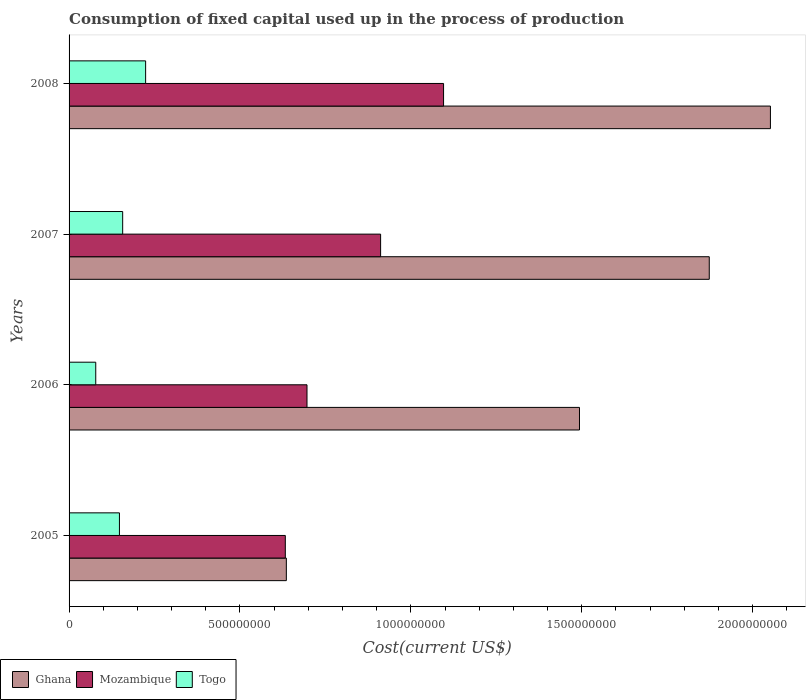Are the number of bars per tick equal to the number of legend labels?
Give a very brief answer. Yes. Are the number of bars on each tick of the Y-axis equal?
Give a very brief answer. Yes. How many bars are there on the 4th tick from the top?
Make the answer very short. 3. How many bars are there on the 2nd tick from the bottom?
Offer a very short reply. 3. What is the amount consumed in the process of production in Mozambique in 2007?
Your response must be concise. 9.12e+08. Across all years, what is the maximum amount consumed in the process of production in Togo?
Keep it short and to the point. 2.24e+08. Across all years, what is the minimum amount consumed in the process of production in Mozambique?
Offer a very short reply. 6.33e+08. In which year was the amount consumed in the process of production in Mozambique minimum?
Your response must be concise. 2005. What is the total amount consumed in the process of production in Ghana in the graph?
Your answer should be very brief. 6.05e+09. What is the difference between the amount consumed in the process of production in Mozambique in 2005 and that in 2007?
Offer a terse response. -2.79e+08. What is the difference between the amount consumed in the process of production in Togo in 2006 and the amount consumed in the process of production in Ghana in 2007?
Your response must be concise. -1.80e+09. What is the average amount consumed in the process of production in Ghana per year?
Keep it short and to the point. 1.51e+09. In the year 2005, what is the difference between the amount consumed in the process of production in Mozambique and amount consumed in the process of production in Togo?
Make the answer very short. 4.85e+08. In how many years, is the amount consumed in the process of production in Ghana greater than 1800000000 US$?
Make the answer very short. 2. What is the ratio of the amount consumed in the process of production in Togo in 2006 to that in 2008?
Your response must be concise. 0.35. What is the difference between the highest and the second highest amount consumed in the process of production in Mozambique?
Offer a very short reply. 1.84e+08. What is the difference between the highest and the lowest amount consumed in the process of production in Mozambique?
Make the answer very short. 4.63e+08. What does the 2nd bar from the top in 2006 represents?
Provide a short and direct response. Mozambique. Is it the case that in every year, the sum of the amount consumed in the process of production in Togo and amount consumed in the process of production in Mozambique is greater than the amount consumed in the process of production in Ghana?
Your answer should be very brief. No. Are all the bars in the graph horizontal?
Make the answer very short. Yes. How many years are there in the graph?
Your response must be concise. 4. What is the difference between two consecutive major ticks on the X-axis?
Give a very brief answer. 5.00e+08. Are the values on the major ticks of X-axis written in scientific E-notation?
Offer a very short reply. No. Does the graph contain any zero values?
Give a very brief answer. No. How many legend labels are there?
Provide a succinct answer. 3. How are the legend labels stacked?
Ensure brevity in your answer.  Horizontal. What is the title of the graph?
Offer a terse response. Consumption of fixed capital used up in the process of production. Does "Madagascar" appear as one of the legend labels in the graph?
Make the answer very short. No. What is the label or title of the X-axis?
Provide a short and direct response. Cost(current US$). What is the Cost(current US$) of Ghana in 2005?
Your answer should be very brief. 6.36e+08. What is the Cost(current US$) of Mozambique in 2005?
Make the answer very short. 6.33e+08. What is the Cost(current US$) of Togo in 2005?
Give a very brief answer. 1.47e+08. What is the Cost(current US$) in Ghana in 2006?
Give a very brief answer. 1.49e+09. What is the Cost(current US$) of Mozambique in 2006?
Provide a short and direct response. 6.96e+08. What is the Cost(current US$) in Togo in 2006?
Provide a succinct answer. 7.81e+07. What is the Cost(current US$) of Ghana in 2007?
Make the answer very short. 1.87e+09. What is the Cost(current US$) of Mozambique in 2007?
Give a very brief answer. 9.12e+08. What is the Cost(current US$) in Togo in 2007?
Give a very brief answer. 1.57e+08. What is the Cost(current US$) in Ghana in 2008?
Your response must be concise. 2.05e+09. What is the Cost(current US$) of Mozambique in 2008?
Your answer should be very brief. 1.10e+09. What is the Cost(current US$) in Togo in 2008?
Offer a very short reply. 2.24e+08. Across all years, what is the maximum Cost(current US$) of Ghana?
Keep it short and to the point. 2.05e+09. Across all years, what is the maximum Cost(current US$) of Mozambique?
Offer a very short reply. 1.10e+09. Across all years, what is the maximum Cost(current US$) of Togo?
Provide a short and direct response. 2.24e+08. Across all years, what is the minimum Cost(current US$) in Ghana?
Give a very brief answer. 6.36e+08. Across all years, what is the minimum Cost(current US$) of Mozambique?
Keep it short and to the point. 6.33e+08. Across all years, what is the minimum Cost(current US$) in Togo?
Make the answer very short. 7.81e+07. What is the total Cost(current US$) of Ghana in the graph?
Ensure brevity in your answer.  6.05e+09. What is the total Cost(current US$) of Mozambique in the graph?
Make the answer very short. 3.34e+09. What is the total Cost(current US$) of Togo in the graph?
Offer a terse response. 6.06e+08. What is the difference between the Cost(current US$) of Ghana in 2005 and that in 2006?
Your answer should be very brief. -8.58e+08. What is the difference between the Cost(current US$) in Mozambique in 2005 and that in 2006?
Provide a succinct answer. -6.34e+07. What is the difference between the Cost(current US$) in Togo in 2005 and that in 2006?
Keep it short and to the point. 6.93e+07. What is the difference between the Cost(current US$) in Ghana in 2005 and that in 2007?
Make the answer very short. -1.24e+09. What is the difference between the Cost(current US$) in Mozambique in 2005 and that in 2007?
Provide a succinct answer. -2.79e+08. What is the difference between the Cost(current US$) in Togo in 2005 and that in 2007?
Provide a succinct answer. -9.45e+06. What is the difference between the Cost(current US$) in Ghana in 2005 and that in 2008?
Offer a terse response. -1.42e+09. What is the difference between the Cost(current US$) in Mozambique in 2005 and that in 2008?
Provide a short and direct response. -4.63e+08. What is the difference between the Cost(current US$) of Togo in 2005 and that in 2008?
Your response must be concise. -7.66e+07. What is the difference between the Cost(current US$) in Ghana in 2006 and that in 2007?
Offer a terse response. -3.80e+08. What is the difference between the Cost(current US$) in Mozambique in 2006 and that in 2007?
Provide a short and direct response. -2.15e+08. What is the difference between the Cost(current US$) in Togo in 2006 and that in 2007?
Make the answer very short. -7.87e+07. What is the difference between the Cost(current US$) of Ghana in 2006 and that in 2008?
Your answer should be compact. -5.59e+08. What is the difference between the Cost(current US$) in Mozambique in 2006 and that in 2008?
Your answer should be very brief. -4.00e+08. What is the difference between the Cost(current US$) in Togo in 2006 and that in 2008?
Your response must be concise. -1.46e+08. What is the difference between the Cost(current US$) in Ghana in 2007 and that in 2008?
Give a very brief answer. -1.79e+08. What is the difference between the Cost(current US$) of Mozambique in 2007 and that in 2008?
Give a very brief answer. -1.84e+08. What is the difference between the Cost(current US$) in Togo in 2007 and that in 2008?
Your answer should be very brief. -6.72e+07. What is the difference between the Cost(current US$) in Ghana in 2005 and the Cost(current US$) in Mozambique in 2006?
Ensure brevity in your answer.  -6.04e+07. What is the difference between the Cost(current US$) in Ghana in 2005 and the Cost(current US$) in Togo in 2006?
Your answer should be very brief. 5.58e+08. What is the difference between the Cost(current US$) in Mozambique in 2005 and the Cost(current US$) in Togo in 2006?
Your answer should be compact. 5.55e+08. What is the difference between the Cost(current US$) of Ghana in 2005 and the Cost(current US$) of Mozambique in 2007?
Keep it short and to the point. -2.76e+08. What is the difference between the Cost(current US$) of Ghana in 2005 and the Cost(current US$) of Togo in 2007?
Your response must be concise. 4.79e+08. What is the difference between the Cost(current US$) of Mozambique in 2005 and the Cost(current US$) of Togo in 2007?
Keep it short and to the point. 4.76e+08. What is the difference between the Cost(current US$) in Ghana in 2005 and the Cost(current US$) in Mozambique in 2008?
Keep it short and to the point. -4.60e+08. What is the difference between the Cost(current US$) of Ghana in 2005 and the Cost(current US$) of Togo in 2008?
Provide a succinct answer. 4.12e+08. What is the difference between the Cost(current US$) of Mozambique in 2005 and the Cost(current US$) of Togo in 2008?
Your response must be concise. 4.09e+08. What is the difference between the Cost(current US$) of Ghana in 2006 and the Cost(current US$) of Mozambique in 2007?
Offer a very short reply. 5.82e+08. What is the difference between the Cost(current US$) of Ghana in 2006 and the Cost(current US$) of Togo in 2007?
Keep it short and to the point. 1.34e+09. What is the difference between the Cost(current US$) in Mozambique in 2006 and the Cost(current US$) in Togo in 2007?
Provide a succinct answer. 5.39e+08. What is the difference between the Cost(current US$) of Ghana in 2006 and the Cost(current US$) of Mozambique in 2008?
Your response must be concise. 3.98e+08. What is the difference between the Cost(current US$) in Ghana in 2006 and the Cost(current US$) in Togo in 2008?
Provide a short and direct response. 1.27e+09. What is the difference between the Cost(current US$) of Mozambique in 2006 and the Cost(current US$) of Togo in 2008?
Offer a terse response. 4.72e+08. What is the difference between the Cost(current US$) of Ghana in 2007 and the Cost(current US$) of Mozambique in 2008?
Keep it short and to the point. 7.77e+08. What is the difference between the Cost(current US$) in Ghana in 2007 and the Cost(current US$) in Togo in 2008?
Keep it short and to the point. 1.65e+09. What is the difference between the Cost(current US$) of Mozambique in 2007 and the Cost(current US$) of Togo in 2008?
Provide a succinct answer. 6.88e+08. What is the average Cost(current US$) in Ghana per year?
Your response must be concise. 1.51e+09. What is the average Cost(current US$) of Mozambique per year?
Offer a very short reply. 8.34e+08. What is the average Cost(current US$) in Togo per year?
Your response must be concise. 1.52e+08. In the year 2005, what is the difference between the Cost(current US$) in Ghana and Cost(current US$) in Mozambique?
Your answer should be compact. 3.01e+06. In the year 2005, what is the difference between the Cost(current US$) of Ghana and Cost(current US$) of Togo?
Your answer should be compact. 4.88e+08. In the year 2005, what is the difference between the Cost(current US$) of Mozambique and Cost(current US$) of Togo?
Provide a short and direct response. 4.85e+08. In the year 2006, what is the difference between the Cost(current US$) of Ghana and Cost(current US$) of Mozambique?
Offer a terse response. 7.97e+08. In the year 2006, what is the difference between the Cost(current US$) of Ghana and Cost(current US$) of Togo?
Keep it short and to the point. 1.42e+09. In the year 2006, what is the difference between the Cost(current US$) in Mozambique and Cost(current US$) in Togo?
Make the answer very short. 6.18e+08. In the year 2007, what is the difference between the Cost(current US$) in Ghana and Cost(current US$) in Mozambique?
Provide a succinct answer. 9.62e+08. In the year 2007, what is the difference between the Cost(current US$) in Ghana and Cost(current US$) in Togo?
Provide a succinct answer. 1.72e+09. In the year 2007, what is the difference between the Cost(current US$) of Mozambique and Cost(current US$) of Togo?
Provide a succinct answer. 7.55e+08. In the year 2008, what is the difference between the Cost(current US$) in Ghana and Cost(current US$) in Mozambique?
Offer a very short reply. 9.56e+08. In the year 2008, what is the difference between the Cost(current US$) in Ghana and Cost(current US$) in Togo?
Your answer should be very brief. 1.83e+09. In the year 2008, what is the difference between the Cost(current US$) in Mozambique and Cost(current US$) in Togo?
Offer a terse response. 8.72e+08. What is the ratio of the Cost(current US$) of Ghana in 2005 to that in 2006?
Make the answer very short. 0.43. What is the ratio of the Cost(current US$) in Mozambique in 2005 to that in 2006?
Give a very brief answer. 0.91. What is the ratio of the Cost(current US$) of Togo in 2005 to that in 2006?
Offer a terse response. 1.89. What is the ratio of the Cost(current US$) of Ghana in 2005 to that in 2007?
Make the answer very short. 0.34. What is the ratio of the Cost(current US$) in Mozambique in 2005 to that in 2007?
Offer a very short reply. 0.69. What is the ratio of the Cost(current US$) of Togo in 2005 to that in 2007?
Provide a succinct answer. 0.94. What is the ratio of the Cost(current US$) of Ghana in 2005 to that in 2008?
Keep it short and to the point. 0.31. What is the ratio of the Cost(current US$) in Mozambique in 2005 to that in 2008?
Provide a succinct answer. 0.58. What is the ratio of the Cost(current US$) of Togo in 2005 to that in 2008?
Provide a short and direct response. 0.66. What is the ratio of the Cost(current US$) of Ghana in 2006 to that in 2007?
Offer a very short reply. 0.8. What is the ratio of the Cost(current US$) of Mozambique in 2006 to that in 2007?
Keep it short and to the point. 0.76. What is the ratio of the Cost(current US$) of Togo in 2006 to that in 2007?
Provide a succinct answer. 0.5. What is the ratio of the Cost(current US$) of Ghana in 2006 to that in 2008?
Ensure brevity in your answer.  0.73. What is the ratio of the Cost(current US$) of Mozambique in 2006 to that in 2008?
Offer a terse response. 0.64. What is the ratio of the Cost(current US$) in Togo in 2006 to that in 2008?
Give a very brief answer. 0.35. What is the ratio of the Cost(current US$) in Ghana in 2007 to that in 2008?
Ensure brevity in your answer.  0.91. What is the ratio of the Cost(current US$) of Mozambique in 2007 to that in 2008?
Ensure brevity in your answer.  0.83. What is the ratio of the Cost(current US$) of Togo in 2007 to that in 2008?
Your answer should be very brief. 0.7. What is the difference between the highest and the second highest Cost(current US$) in Ghana?
Offer a very short reply. 1.79e+08. What is the difference between the highest and the second highest Cost(current US$) in Mozambique?
Your response must be concise. 1.84e+08. What is the difference between the highest and the second highest Cost(current US$) in Togo?
Your response must be concise. 6.72e+07. What is the difference between the highest and the lowest Cost(current US$) in Ghana?
Your answer should be compact. 1.42e+09. What is the difference between the highest and the lowest Cost(current US$) in Mozambique?
Your answer should be compact. 4.63e+08. What is the difference between the highest and the lowest Cost(current US$) in Togo?
Your answer should be compact. 1.46e+08. 